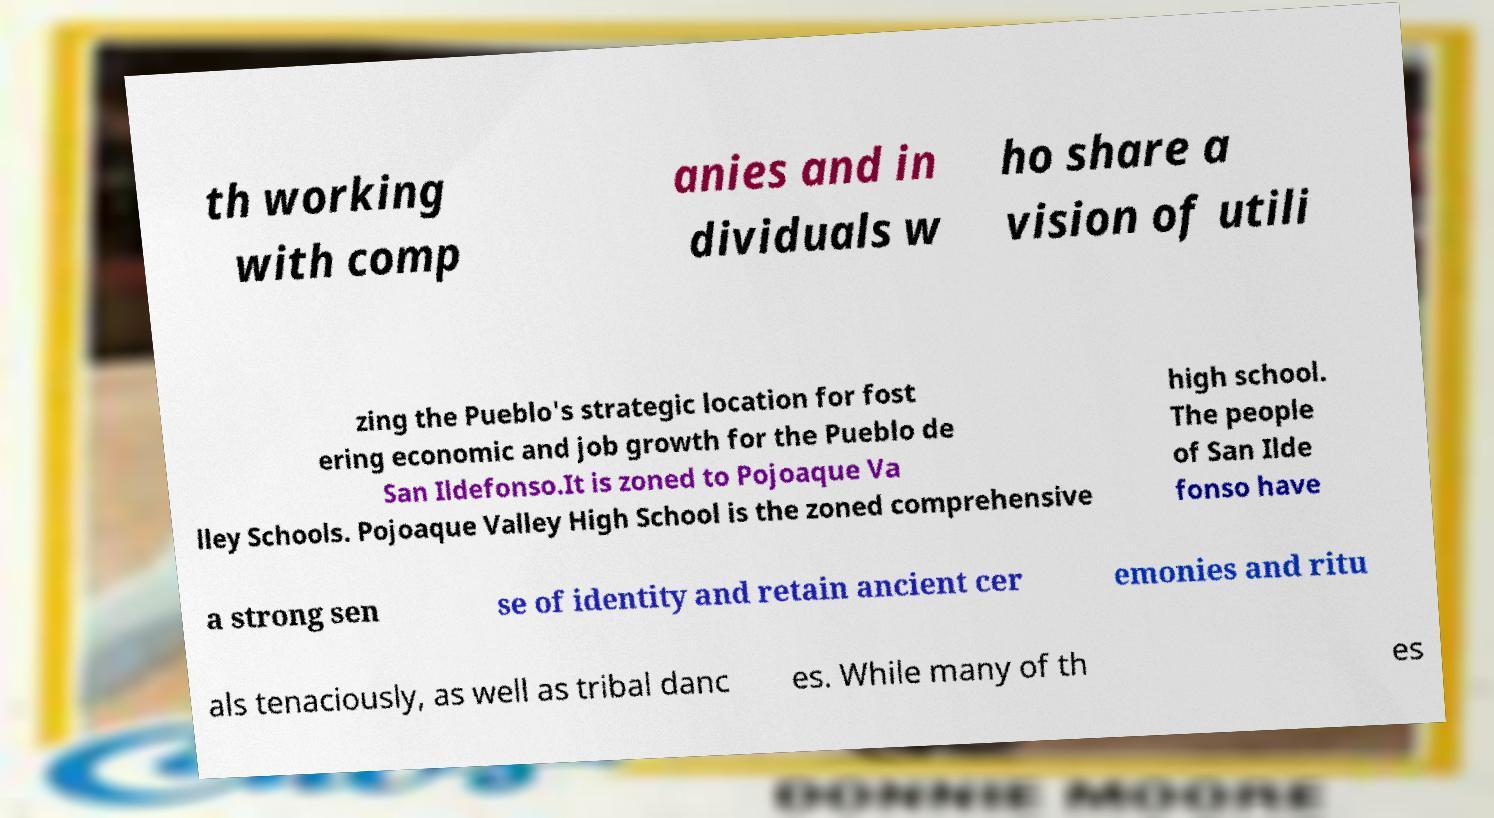Please identify and transcribe the text found in this image. th working with comp anies and in dividuals w ho share a vision of utili zing the Pueblo's strategic location for fost ering economic and job growth for the Pueblo de San Ildefonso.It is zoned to Pojoaque Va lley Schools. Pojoaque Valley High School is the zoned comprehensive high school. The people of San Ilde fonso have a strong sen se of identity and retain ancient cer emonies and ritu als tenaciously, as well as tribal danc es. While many of th es 